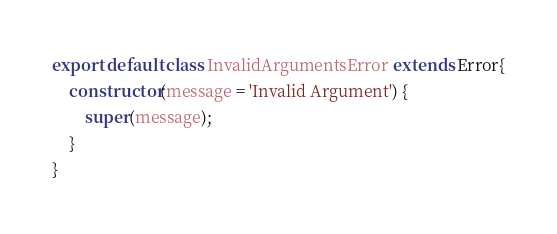Convert code to text. <code><loc_0><loc_0><loc_500><loc_500><_JavaScript_>export default class InvalidArgumentsError extends Error{
    constructor(message = 'Invalid Argument') {
        super(message);
    }
}</code> 